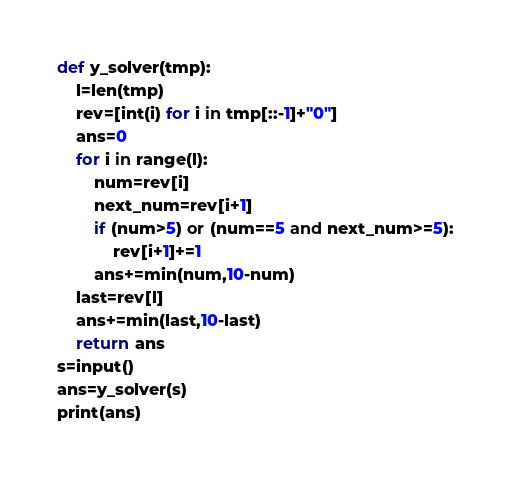<code> <loc_0><loc_0><loc_500><loc_500><_Python_>def y_solver(tmp):
    l=len(tmp)
    rev=[int(i) for i in tmp[::-1]+"0"]
    ans=0
    for i in range(l):
        num=rev[i]
        next_num=rev[i+1]
        if (num>5) or (num==5 and next_num>=5):
            rev[i+1]+=1
        ans+=min(num,10-num)  
    last=rev[l]
    ans+=min(last,10-last)
    return ans
s=input()
ans=y_solver(s)
print(ans)</code> 